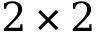Convert formula to latex. <formula><loc_0><loc_0><loc_500><loc_500>2 \times 2</formula> 